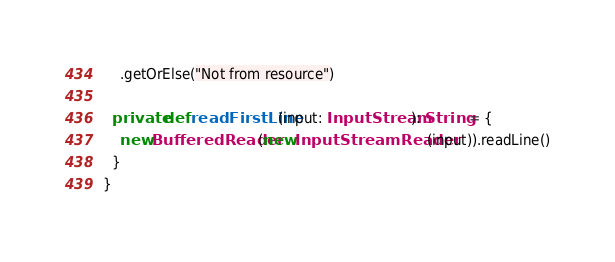Convert code to text. <code><loc_0><loc_0><loc_500><loc_500><_Scala_>    .getOrElse("Not from resource")

  private def readFirstLine(input: InputStream): String = {
    new BufferedReader(new InputStreamReader(input)).readLine()
  }
}
</code> 